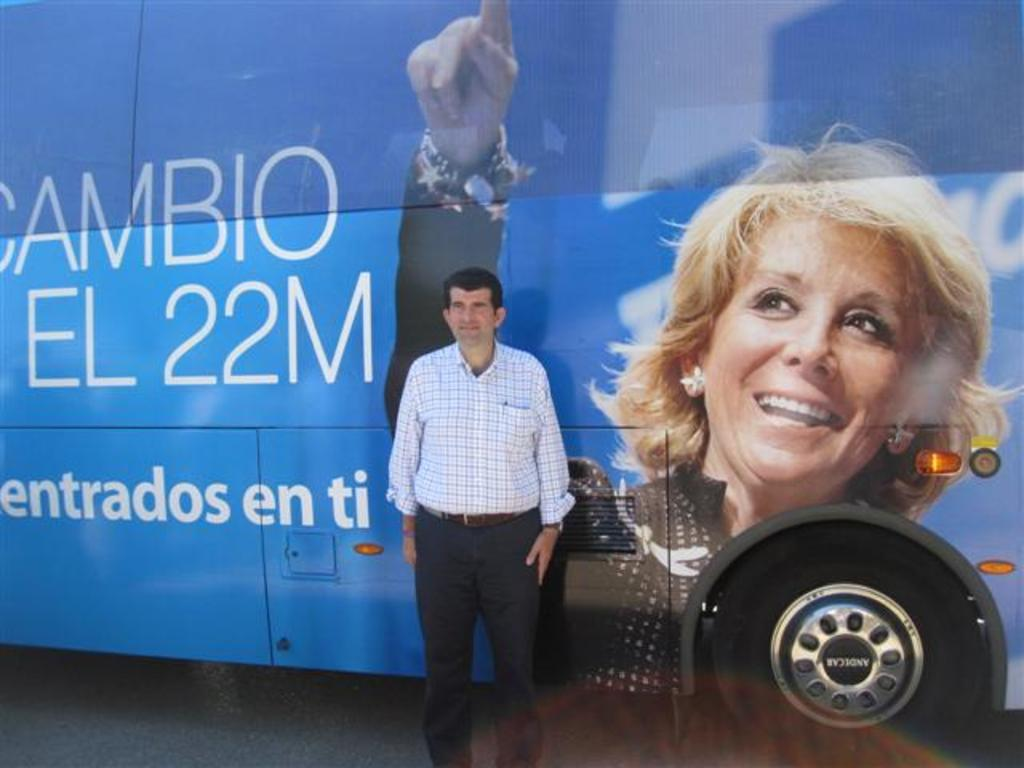What is the main subject of the image? There is a person standing in the image. What else can be seen in the image besides the person? There is a bus in the image. Can you describe the bus in the image? The bus has a woman's photo on it and is blue in color. How many books are visible on the snow in the park in the image? There is no snow, park, or books present in the image. 